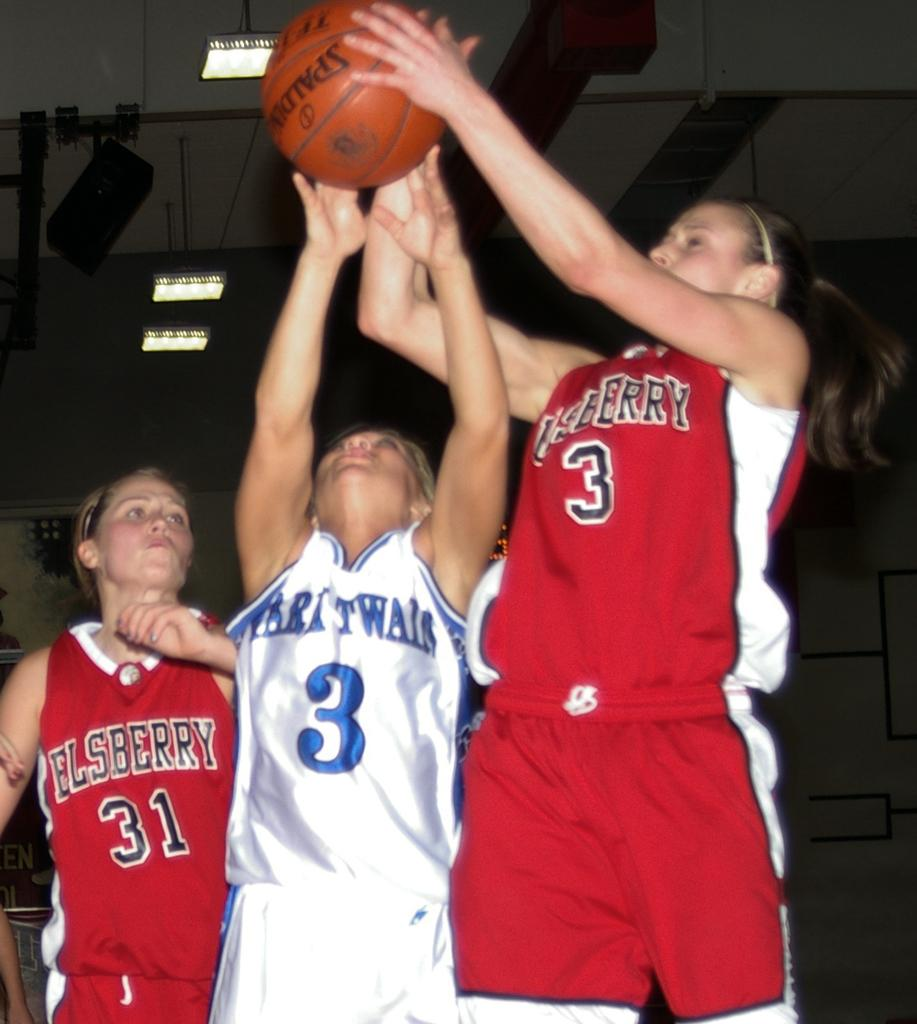<image>
Offer a succinct explanation of the picture presented. Elsberry basketball player number 3 blocks a shot by number 3 on the white team. 